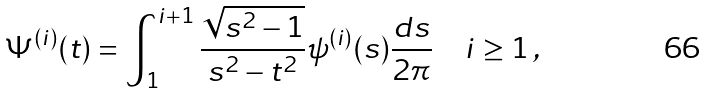Convert formula to latex. <formula><loc_0><loc_0><loc_500><loc_500>\Psi ^ { ( i ) } ( t ) = \int _ { 1 } ^ { i + 1 } \frac { \sqrt { s ^ { 2 } - 1 } } { s ^ { 2 } - t ^ { 2 } } \psi ^ { ( i ) } ( s ) \frac { d s } { 2 \pi } \quad i \geq 1 \, ,</formula> 